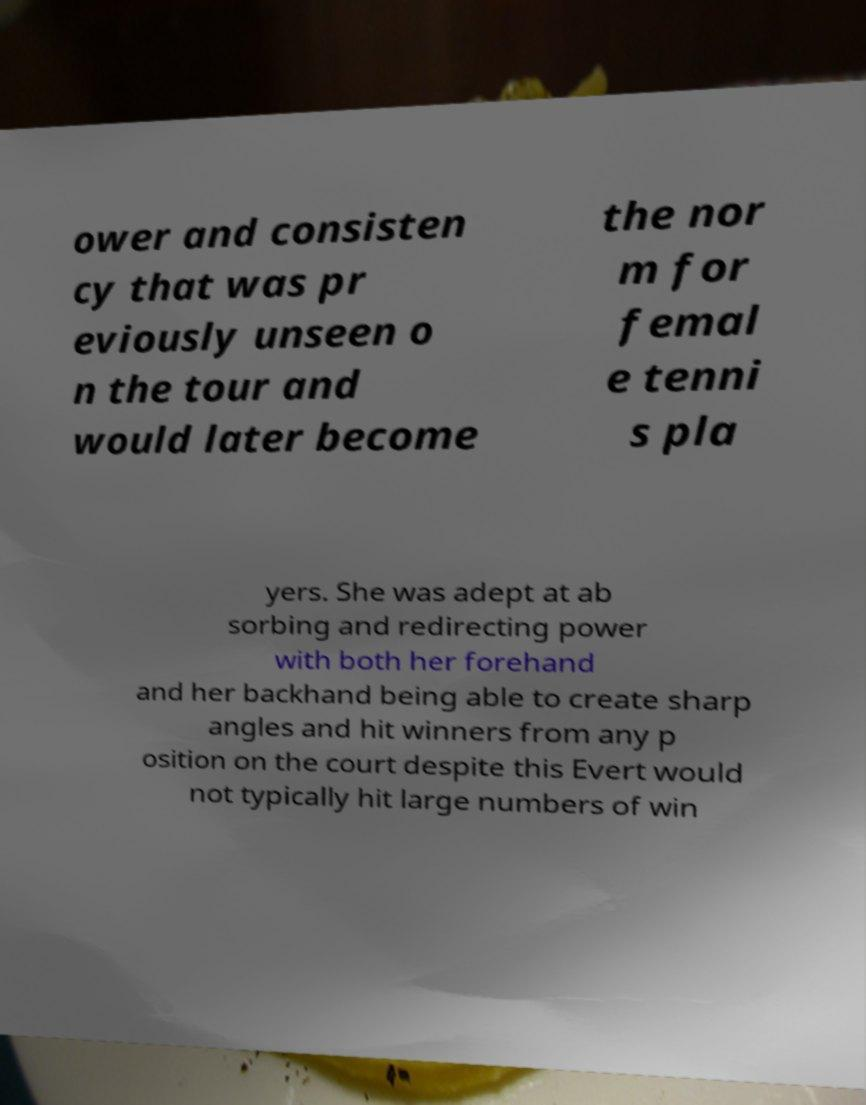Can you read and provide the text displayed in the image?This photo seems to have some interesting text. Can you extract and type it out for me? ower and consisten cy that was pr eviously unseen o n the tour and would later become the nor m for femal e tenni s pla yers. She was adept at ab sorbing and redirecting power with both her forehand and her backhand being able to create sharp angles and hit winners from any p osition on the court despite this Evert would not typically hit large numbers of win 